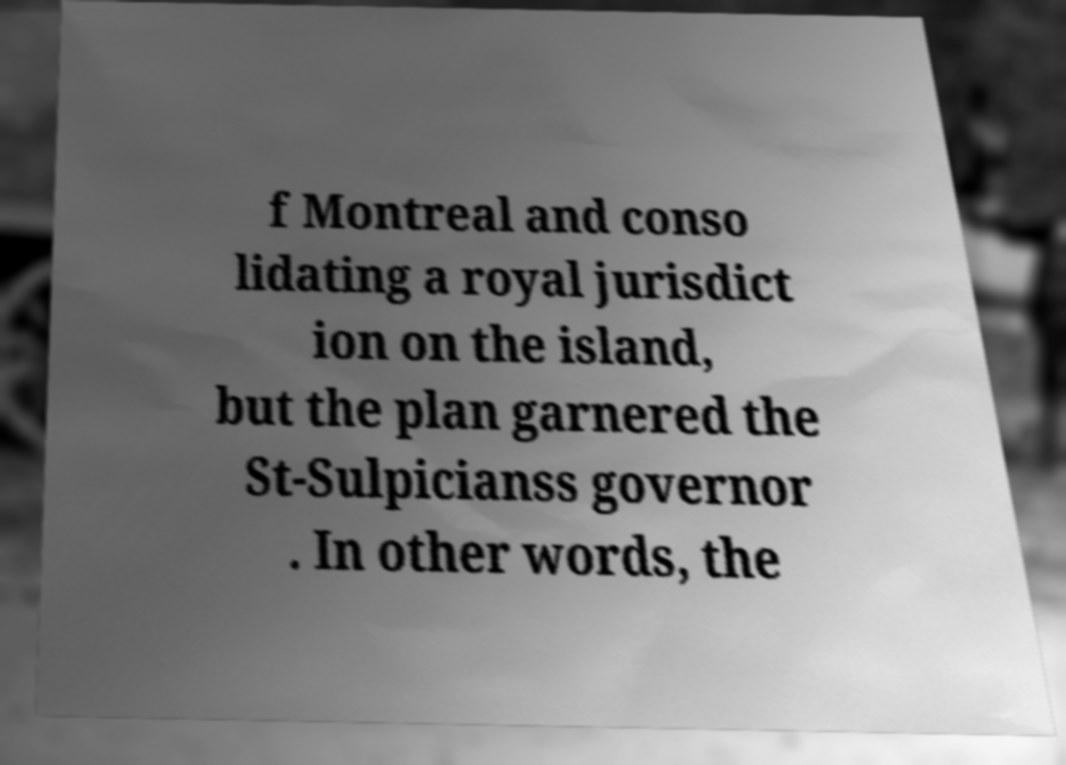For documentation purposes, I need the text within this image transcribed. Could you provide that? f Montreal and conso lidating a royal jurisdict ion on the island, but the plan garnered the St-Sulpicianss governor . In other words, the 